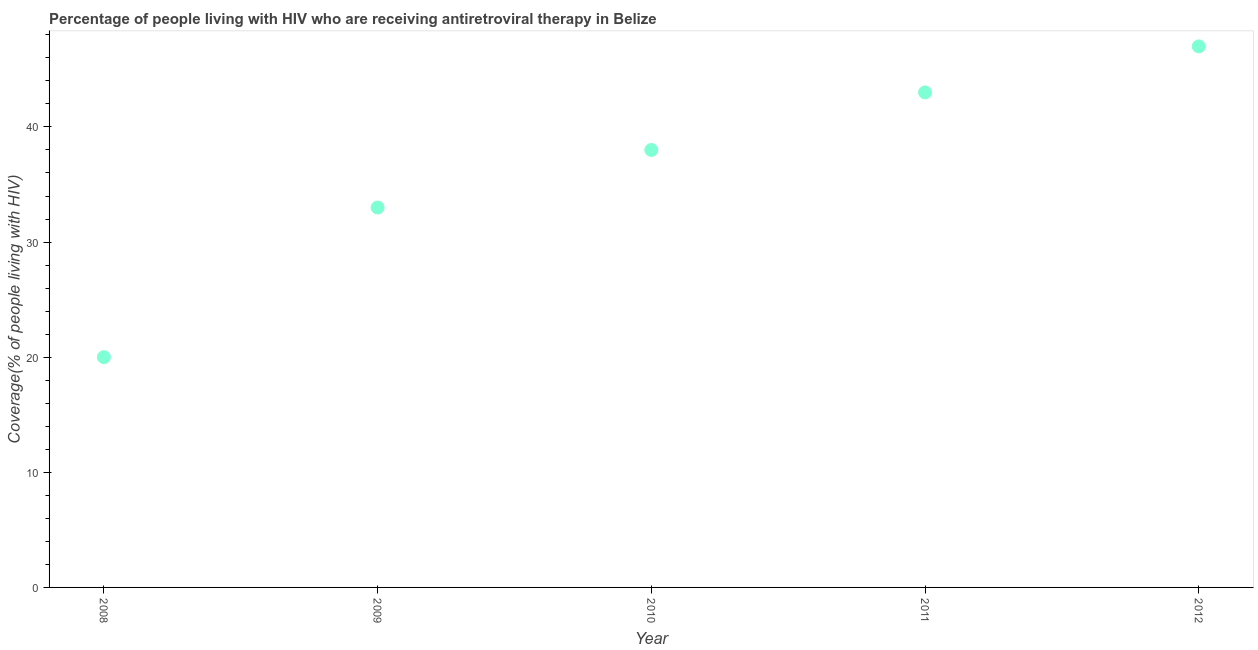What is the antiretroviral therapy coverage in 2011?
Provide a short and direct response. 43. Across all years, what is the maximum antiretroviral therapy coverage?
Offer a very short reply. 47. Across all years, what is the minimum antiretroviral therapy coverage?
Your response must be concise. 20. What is the sum of the antiretroviral therapy coverage?
Provide a short and direct response. 181. What is the difference between the antiretroviral therapy coverage in 2009 and 2011?
Offer a very short reply. -10. What is the average antiretroviral therapy coverage per year?
Offer a terse response. 36.2. Do a majority of the years between 2010 and 2011 (inclusive) have antiretroviral therapy coverage greater than 6 %?
Provide a short and direct response. Yes. What is the ratio of the antiretroviral therapy coverage in 2009 to that in 2011?
Offer a terse response. 0.77. Is the antiretroviral therapy coverage in 2009 less than that in 2010?
Offer a very short reply. Yes. Is the difference between the antiretroviral therapy coverage in 2010 and 2011 greater than the difference between any two years?
Ensure brevity in your answer.  No. What is the difference between the highest and the second highest antiretroviral therapy coverage?
Offer a terse response. 4. What is the difference between the highest and the lowest antiretroviral therapy coverage?
Your answer should be compact. 27. In how many years, is the antiretroviral therapy coverage greater than the average antiretroviral therapy coverage taken over all years?
Make the answer very short. 3. Does the antiretroviral therapy coverage monotonically increase over the years?
Ensure brevity in your answer.  Yes. How many dotlines are there?
Offer a very short reply. 1. How many years are there in the graph?
Offer a terse response. 5. What is the difference between two consecutive major ticks on the Y-axis?
Provide a short and direct response. 10. Does the graph contain any zero values?
Offer a terse response. No. What is the title of the graph?
Offer a very short reply. Percentage of people living with HIV who are receiving antiretroviral therapy in Belize. What is the label or title of the X-axis?
Your response must be concise. Year. What is the label or title of the Y-axis?
Provide a succinct answer. Coverage(% of people living with HIV). What is the Coverage(% of people living with HIV) in 2010?
Offer a very short reply. 38. What is the difference between the Coverage(% of people living with HIV) in 2008 and 2011?
Make the answer very short. -23. What is the difference between the Coverage(% of people living with HIV) in 2009 and 2010?
Your response must be concise. -5. What is the difference between the Coverage(% of people living with HIV) in 2009 and 2011?
Your answer should be very brief. -10. What is the difference between the Coverage(% of people living with HIV) in 2009 and 2012?
Your answer should be very brief. -14. What is the difference between the Coverage(% of people living with HIV) in 2010 and 2011?
Offer a terse response. -5. What is the ratio of the Coverage(% of people living with HIV) in 2008 to that in 2009?
Your answer should be compact. 0.61. What is the ratio of the Coverage(% of people living with HIV) in 2008 to that in 2010?
Your answer should be very brief. 0.53. What is the ratio of the Coverage(% of people living with HIV) in 2008 to that in 2011?
Offer a very short reply. 0.47. What is the ratio of the Coverage(% of people living with HIV) in 2008 to that in 2012?
Your answer should be compact. 0.43. What is the ratio of the Coverage(% of people living with HIV) in 2009 to that in 2010?
Your response must be concise. 0.87. What is the ratio of the Coverage(% of people living with HIV) in 2009 to that in 2011?
Offer a terse response. 0.77. What is the ratio of the Coverage(% of people living with HIV) in 2009 to that in 2012?
Make the answer very short. 0.7. What is the ratio of the Coverage(% of people living with HIV) in 2010 to that in 2011?
Give a very brief answer. 0.88. What is the ratio of the Coverage(% of people living with HIV) in 2010 to that in 2012?
Your answer should be very brief. 0.81. What is the ratio of the Coverage(% of people living with HIV) in 2011 to that in 2012?
Offer a very short reply. 0.92. 